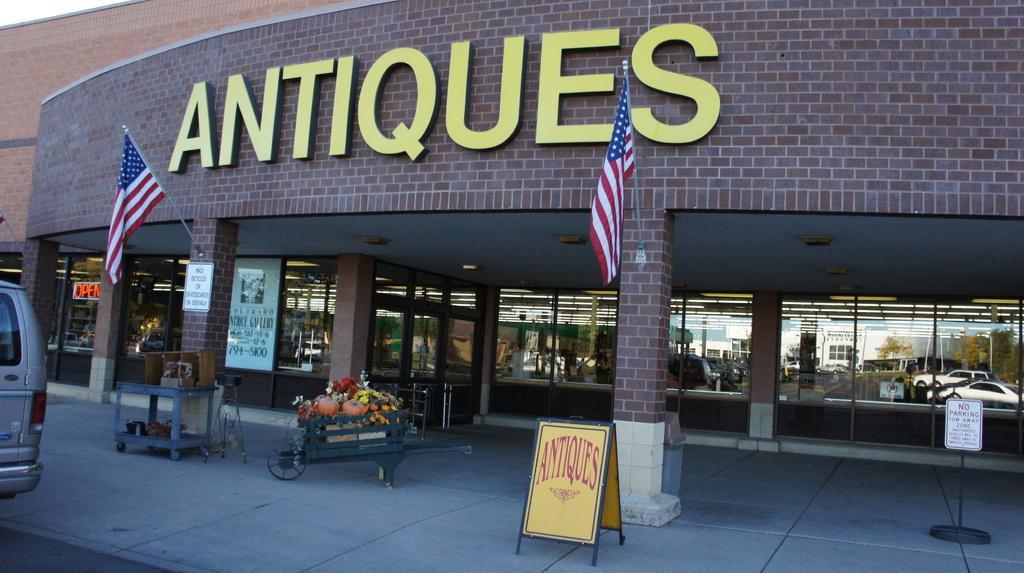Describe this image in one or two sentences. In this image we can see a building, pillars, boards, cart, pumpkins, flowers, and glasses. On the glasses we can see the reflection of buildings, trees, poles, vehicles, and sky. 